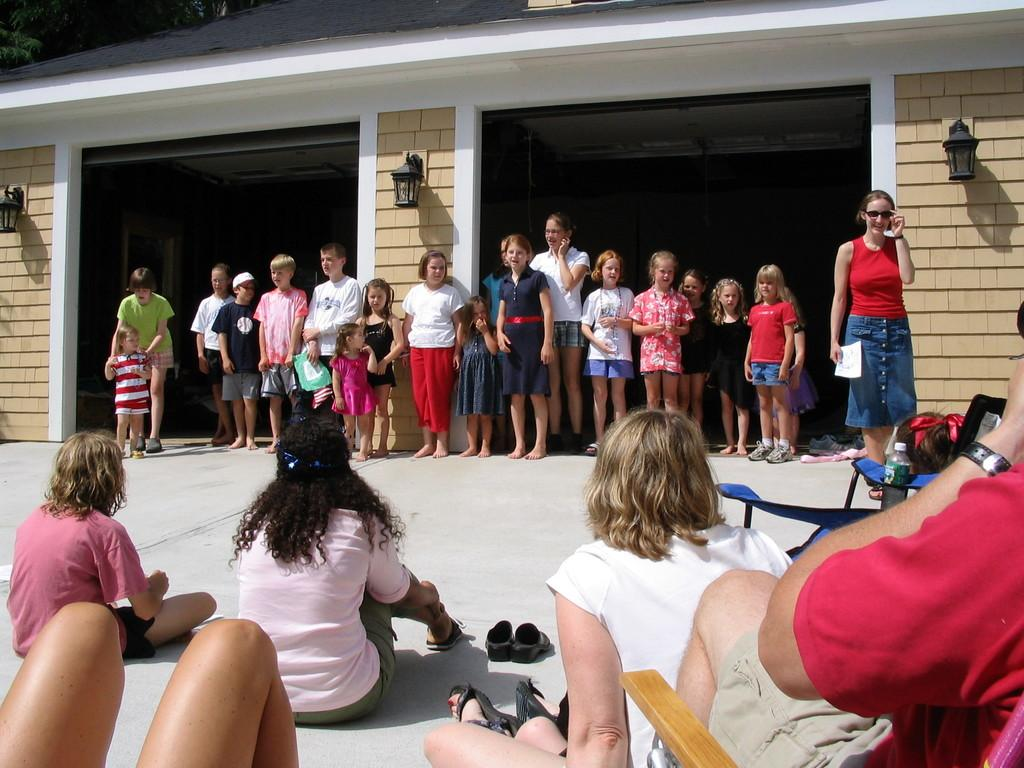What is the gender of the people sitting on the left side of the image? There are women sitting on the left side of the image. What is the gender of the people standing on the left side of the image? There are boys standing on the left side of the image. What is the gender of the people standing on the right side of the image? There are girls standing on the right side of the image. What type of patch can be seen on the nose of the person in the image? There is no patch visible on anyone's nose in the image. How many pockets are visible on the clothing of the people in the image? The provided facts do not mention pockets, so we cannot determine the number of pockets visible in the image. 